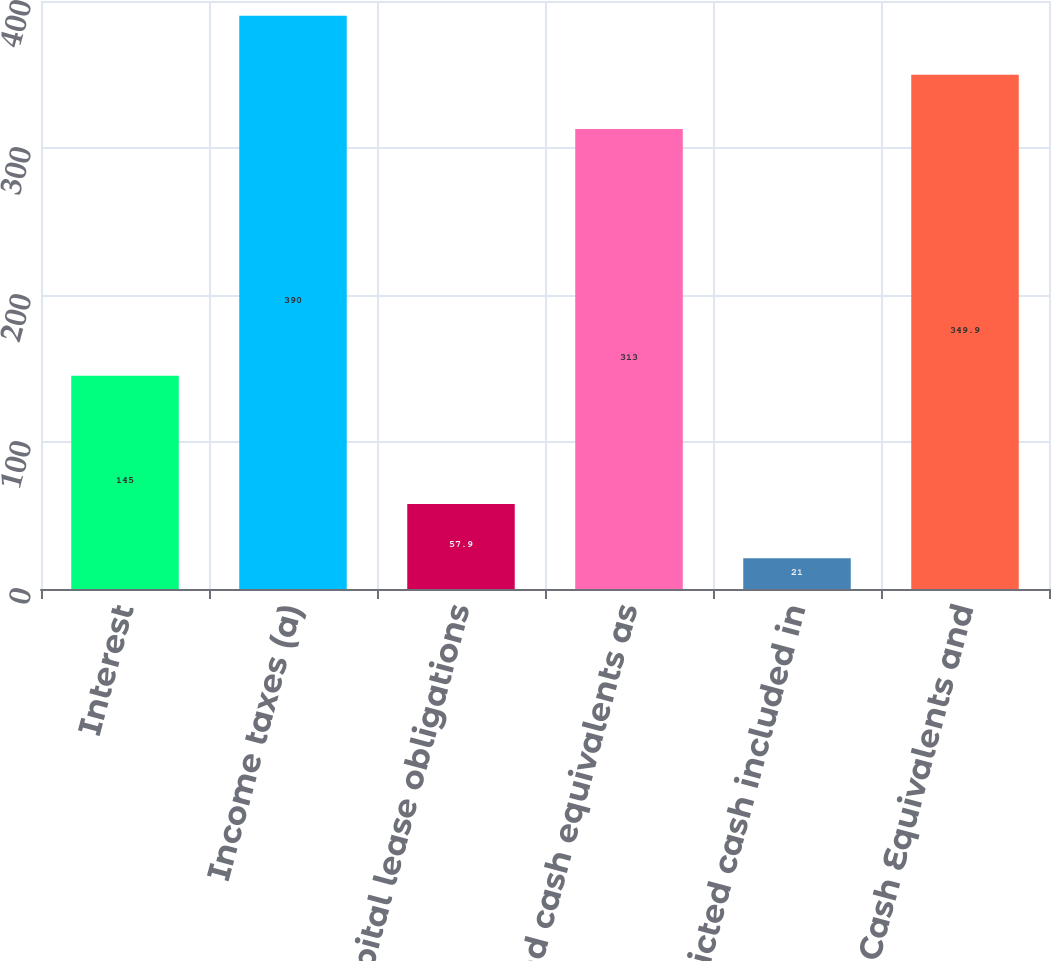Convert chart. <chart><loc_0><loc_0><loc_500><loc_500><bar_chart><fcel>Interest<fcel>Income taxes (a)<fcel>Capital lease obligations<fcel>Cash and cash equivalents as<fcel>Restricted cash included in<fcel>Cash Cash Equivalents and<nl><fcel>145<fcel>390<fcel>57.9<fcel>313<fcel>21<fcel>349.9<nl></chart> 